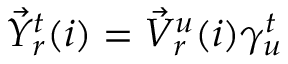<formula> <loc_0><loc_0><loc_500><loc_500>\begin{array} { r } { \vec { Y } _ { r } ^ { t } ( i ) = \vec { V } _ { r } ^ { u } ( i ) \gamma _ { u } ^ { t } } \end{array}</formula> 